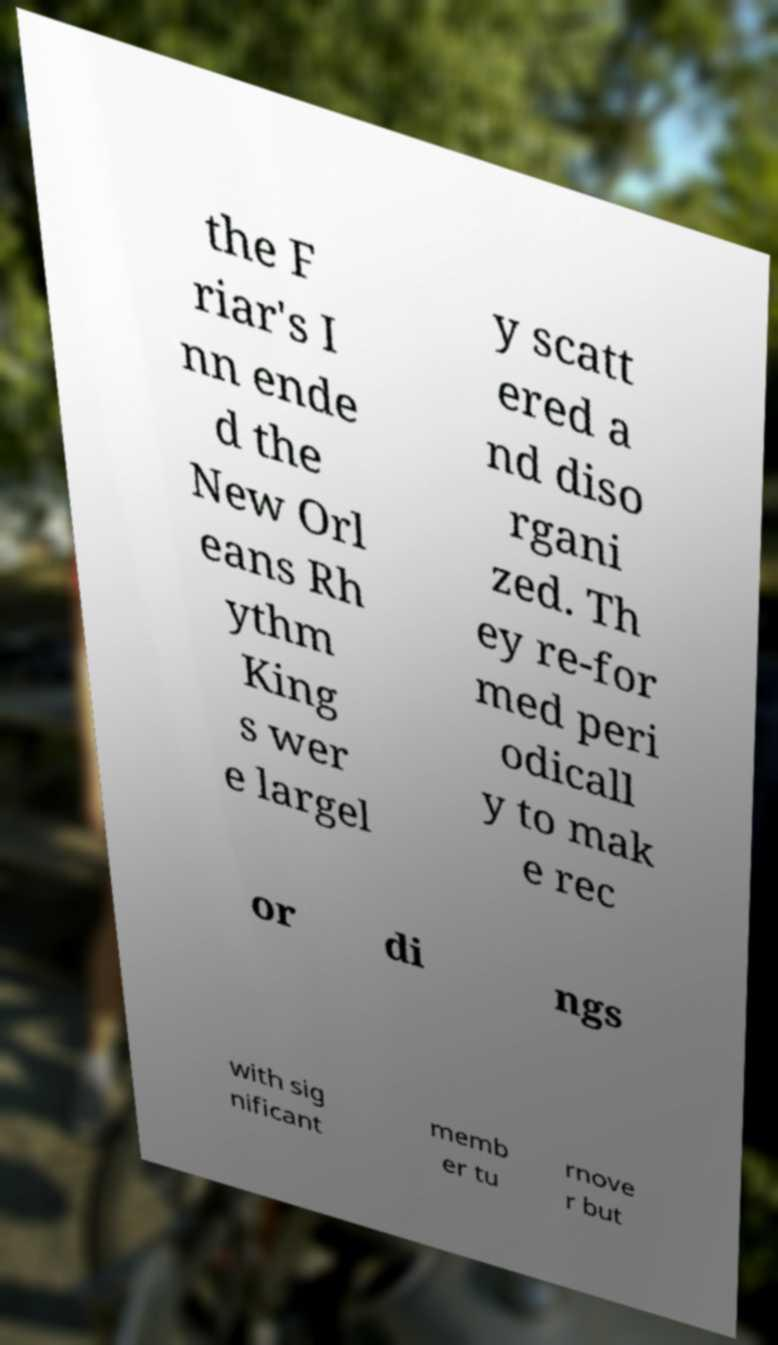Can you accurately transcribe the text from the provided image for me? the F riar's I nn ende d the New Orl eans Rh ythm King s wer e largel y scatt ered a nd diso rgani zed. Th ey re-for med peri odicall y to mak e rec or di ngs with sig nificant memb er tu rnove r but 